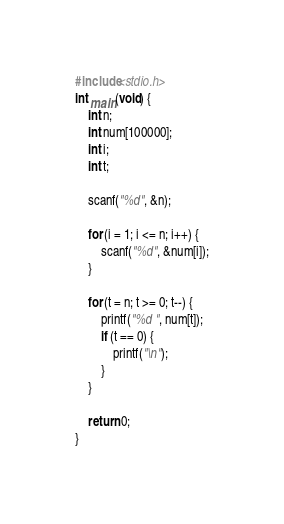Convert code to text. <code><loc_0><loc_0><loc_500><loc_500><_C_>#include<stdio.h>
int main(void) {
	int n;
	int num[100000];
	int i;
	int t;

	scanf("%d", &n);

	for (i = 1; i <= n; i++) {
		scanf("%d", &num[i]);
	}

	for (t = n; t >= 0; t--) {
		printf("%d ", num[t]);
		if (t == 0) {
			printf("\n");
		}
	}
	
	return 0;
}</code> 